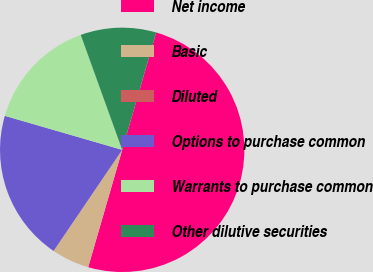<chart> <loc_0><loc_0><loc_500><loc_500><pie_chart><fcel>Net income<fcel>Basic<fcel>Diluted<fcel>Options to purchase common<fcel>Warrants to purchase common<fcel>Other dilutive securities<nl><fcel>50.0%<fcel>5.0%<fcel>0.0%<fcel>20.0%<fcel>15.0%<fcel>10.0%<nl></chart> 